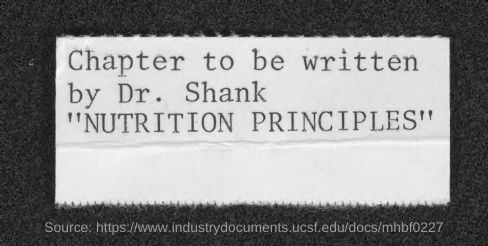Give some essential details in this illustration. It is imperative that Dr. Shank writes the chapter. 